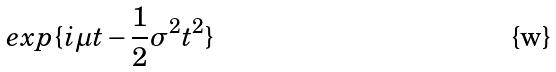Convert formula to latex. <formula><loc_0><loc_0><loc_500><loc_500>e x p \{ i \mu t - \frac { 1 } { 2 } \sigma ^ { 2 } t ^ { 2 } \}</formula> 